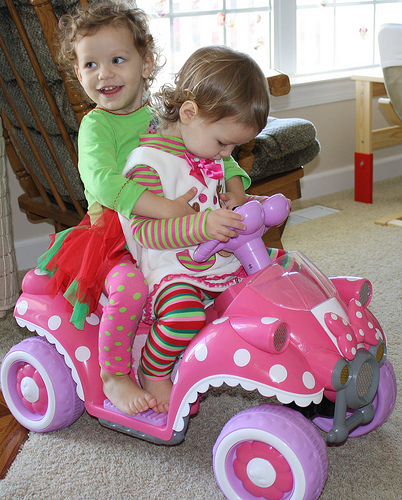<image>
Can you confirm if the dress is on the girl? No. The dress is not positioned on the girl. They may be near each other, but the dress is not supported by or resting on top of the girl. Is the chair behind the girl? Yes. From this viewpoint, the chair is positioned behind the girl, with the girl partially or fully occluding the chair. 